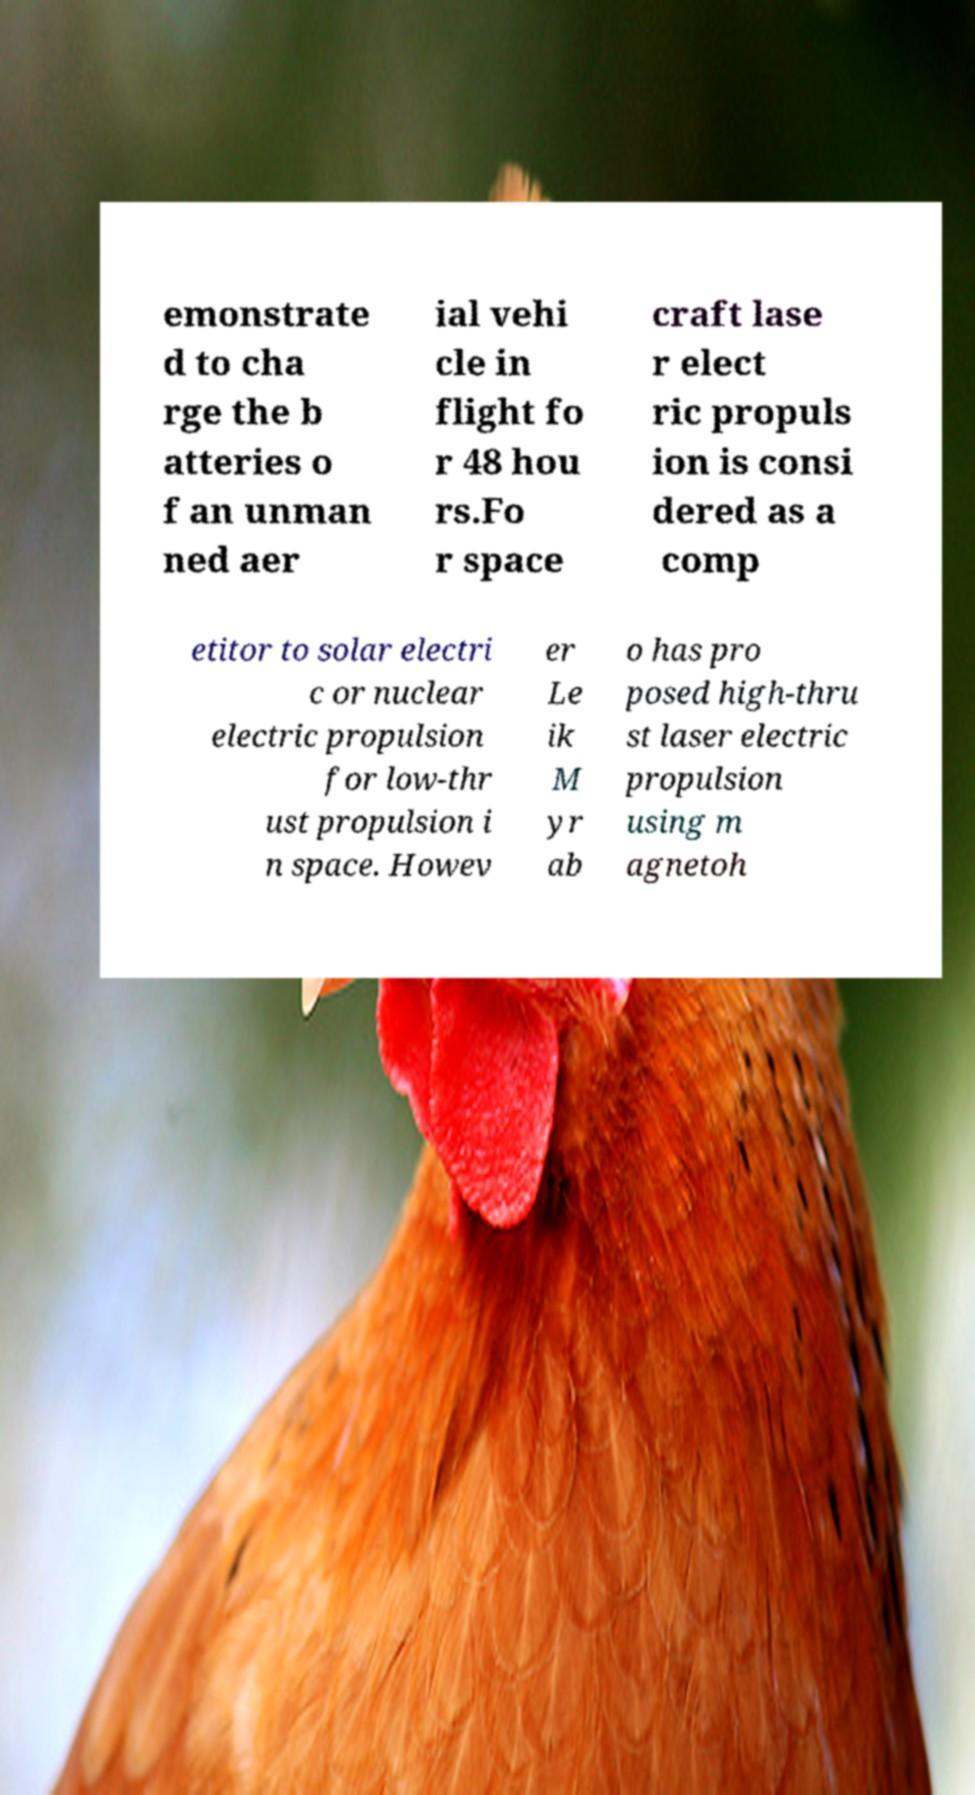Please identify and transcribe the text found in this image. emonstrate d to cha rge the b atteries o f an unman ned aer ial vehi cle in flight fo r 48 hou rs.Fo r space craft lase r elect ric propuls ion is consi dered as a comp etitor to solar electri c or nuclear electric propulsion for low-thr ust propulsion i n space. Howev er Le ik M yr ab o has pro posed high-thru st laser electric propulsion using m agnetoh 